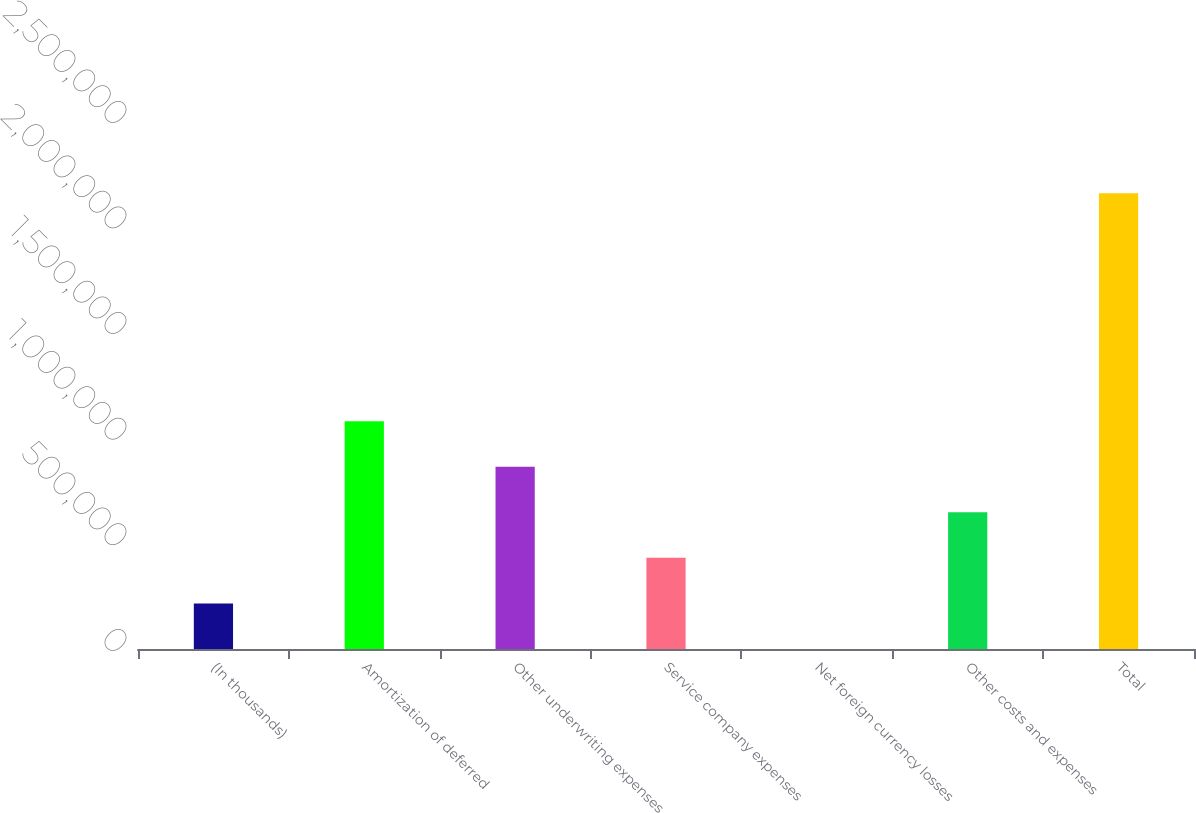Convert chart. <chart><loc_0><loc_0><loc_500><loc_500><bar_chart><fcel>(In thousands)<fcel>Amortization of deferred<fcel>Other underwriting expenses<fcel>Service company expenses<fcel>Net foreign currency losses<fcel>Other costs and expenses<fcel>Total<nl><fcel>215770<fcel>1.07874e+06<fcel>862999<fcel>431513<fcel>27<fcel>647256<fcel>2.15746e+06<nl></chart> 